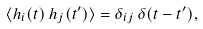<formula> <loc_0><loc_0><loc_500><loc_500>& \langle h _ { i } ( t ) \, h _ { j } ( t ^ { \prime } ) \rangle = \delta _ { i j } \, \delta ( t - t ^ { \prime } ) ,</formula> 